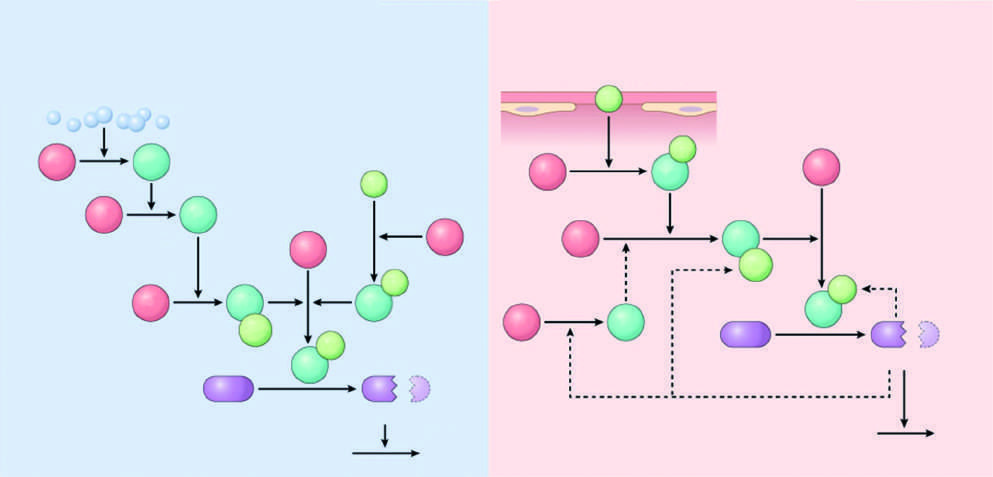what color are the active factors?
Answer the question using a single word or phrase. Dark green 